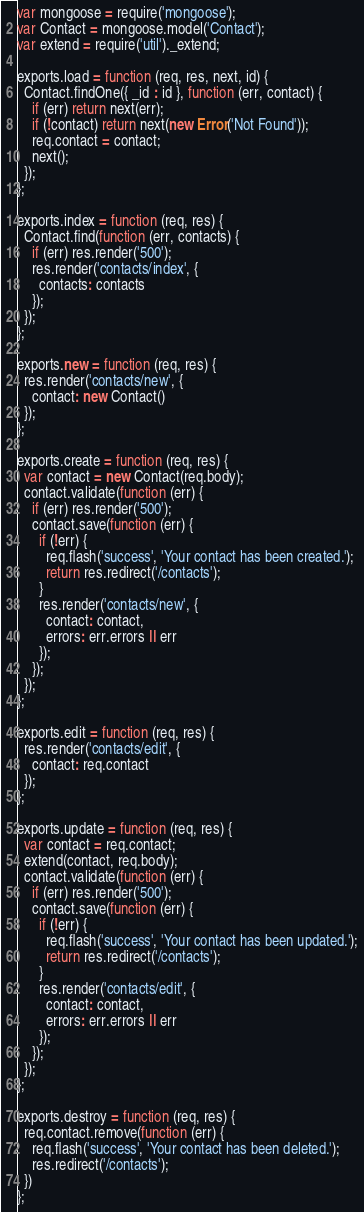<code> <loc_0><loc_0><loc_500><loc_500><_JavaScript_>var mongoose = require('mongoose');
var Contact = mongoose.model('Contact');
var extend = require('util')._extend;

exports.load = function (req, res, next, id) {
  Contact.findOne({ _id : id }, function (err, contact) {
    if (err) return next(err);
    if (!contact) return next(new Error('Not Found'));
    req.contact = contact;
    next();
  });
};

exports.index = function (req, res) {
  Contact.find(function (err, contacts) {
    if (err) res.render('500');
    res.render('contacts/index', {
      contacts: contacts
    });
  });
};

exports.new = function (req, res) {
  res.render('contacts/new', {
    contact: new Contact()
  });
};

exports.create = function (req, res) {
  var contact = new Contact(req.body);
  contact.validate(function (err) {
    if (err) res.render('500');
    contact.save(function (err) {
      if (!err) {
        req.flash('success', 'Your contact has been created.');
        return res.redirect('/contacts');
      }
      res.render('contacts/new', {
        contact: contact,
        errors: err.errors || err
      });
    });
  });
};

exports.edit = function (req, res) {
  res.render('contacts/edit', {
    contact: req.contact
  });
};

exports.update = function (req, res) {
  var contact = req.contact;
  extend(contact, req.body);
  contact.validate(function (err) {
    if (err) res.render('500');
    contact.save(function (err) {
      if (!err) {
        req.flash('success', 'Your contact has been updated.');
        return res.redirect('/contacts');
      }
      res.render('contacts/edit', {
        contact: contact,
        errors: err.errors || err
      });
    });
  });
};

exports.destroy = function (req, res) {
  req.contact.remove(function (err) {
    req.flash('success', 'Your contact has been deleted.');
    res.redirect('/contacts');
  })
};
</code> 